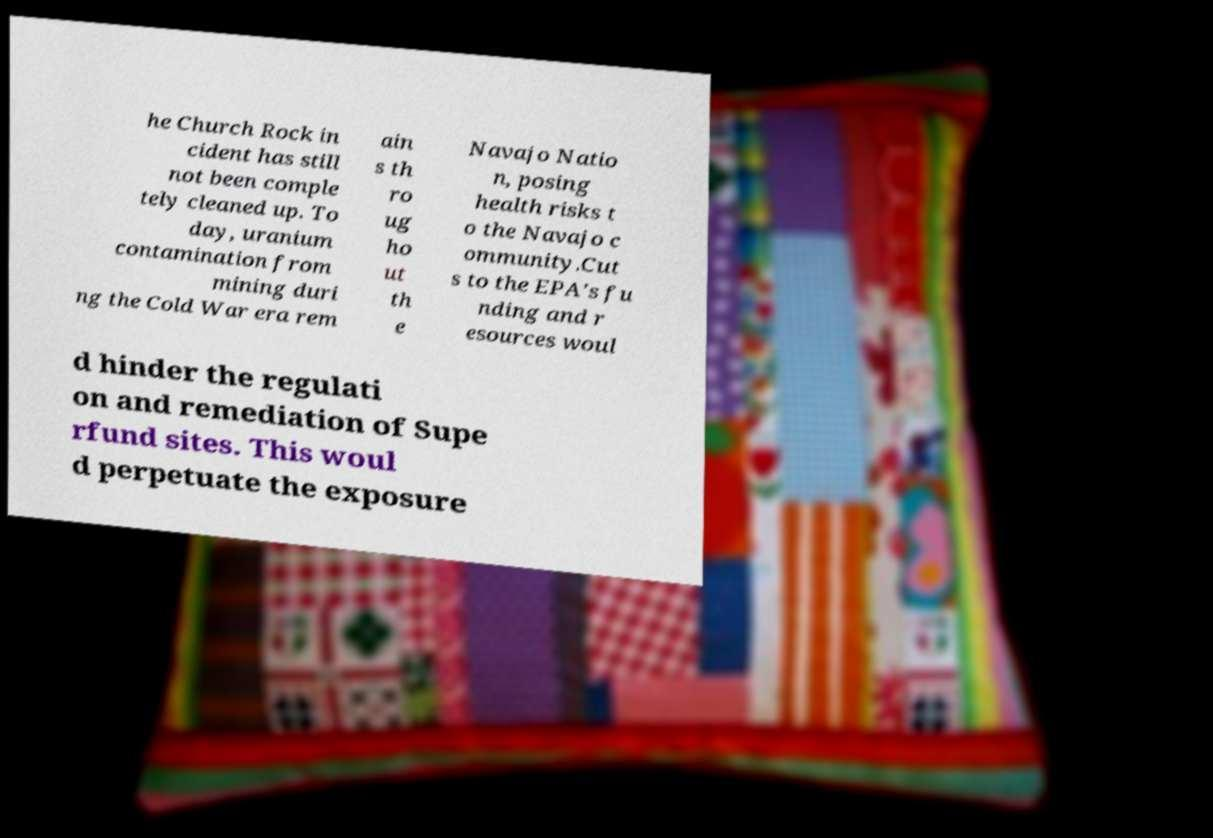Can you read and provide the text displayed in the image?This photo seems to have some interesting text. Can you extract and type it out for me? he Church Rock in cident has still not been comple tely cleaned up. To day, uranium contamination from mining duri ng the Cold War era rem ain s th ro ug ho ut th e Navajo Natio n, posing health risks t o the Navajo c ommunity.Cut s to the EPA's fu nding and r esources woul d hinder the regulati on and remediation of Supe rfund sites. This woul d perpetuate the exposure 